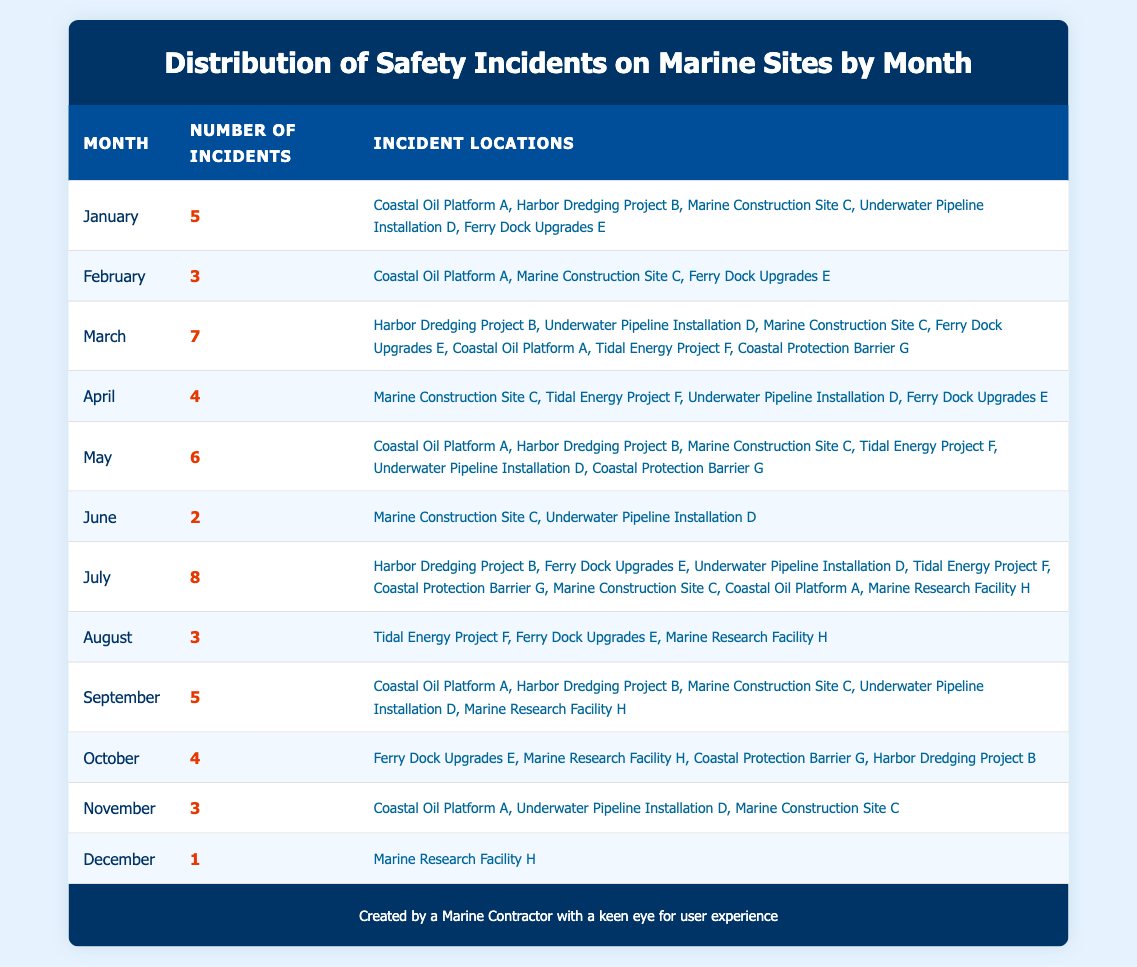What month had the highest number of safety incidents? By reviewing the 'Number of Incidents' column, July has the highest count with 8 incidents.
Answer: July How many safety incidents occurred in March? The table states that March had 7 safety incidents, as indicated in the 'Number of Incidents' column.
Answer: 7 Which months had exactly 3 safety incidents? Looking at the table, February, August, and November each had 3 incidents.
Answer: February, August, November What is the total number of safety incidents from January to March? To find the total, we add the incidents from January (5), February (3), and March (7). Thus, 5 + 3 + 7 equals 15.
Answer: 15 Did the Coastal Oil Platform A experience safety incidents in every month? By checking the locations in each month, Coastal Oil Platform A is listed in January, February, March, May, September, and November, but not in April, June, July, August, or December.
Answer: No What was the average number of incidents in the months of June, July, and August? The incidents in June, July, and August are 2, 8, and 3 respectively. The sum is 2 + 8 + 3 = 13. Since there are 3 months, the average is 13 divided by 3, which is approximately 4.33.
Answer: 4.33 In which month did the lowest number of incidents occur and what was the count? December has the lowest count with only 1 incident, as detailed in the table under the 'Number of Incidents' column.
Answer: December, 1 Which project had the most locations involved in safety incidents in March? In March, the 'Locations' listed include 7 different projects. The maximum number of unique incident locations is the highest number found in any month, which is 7.
Answer: 7 